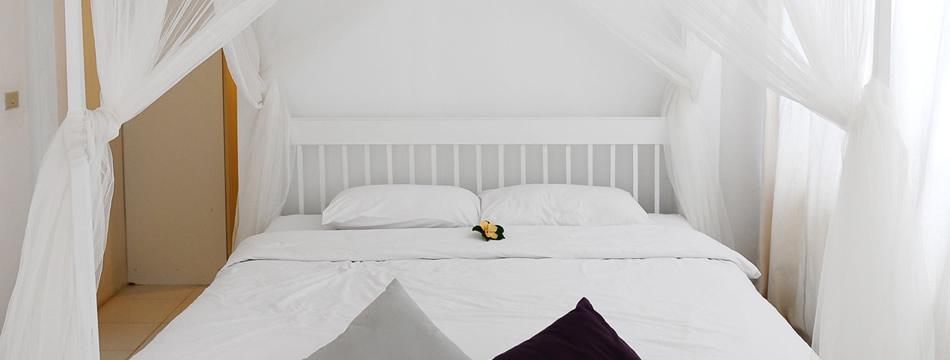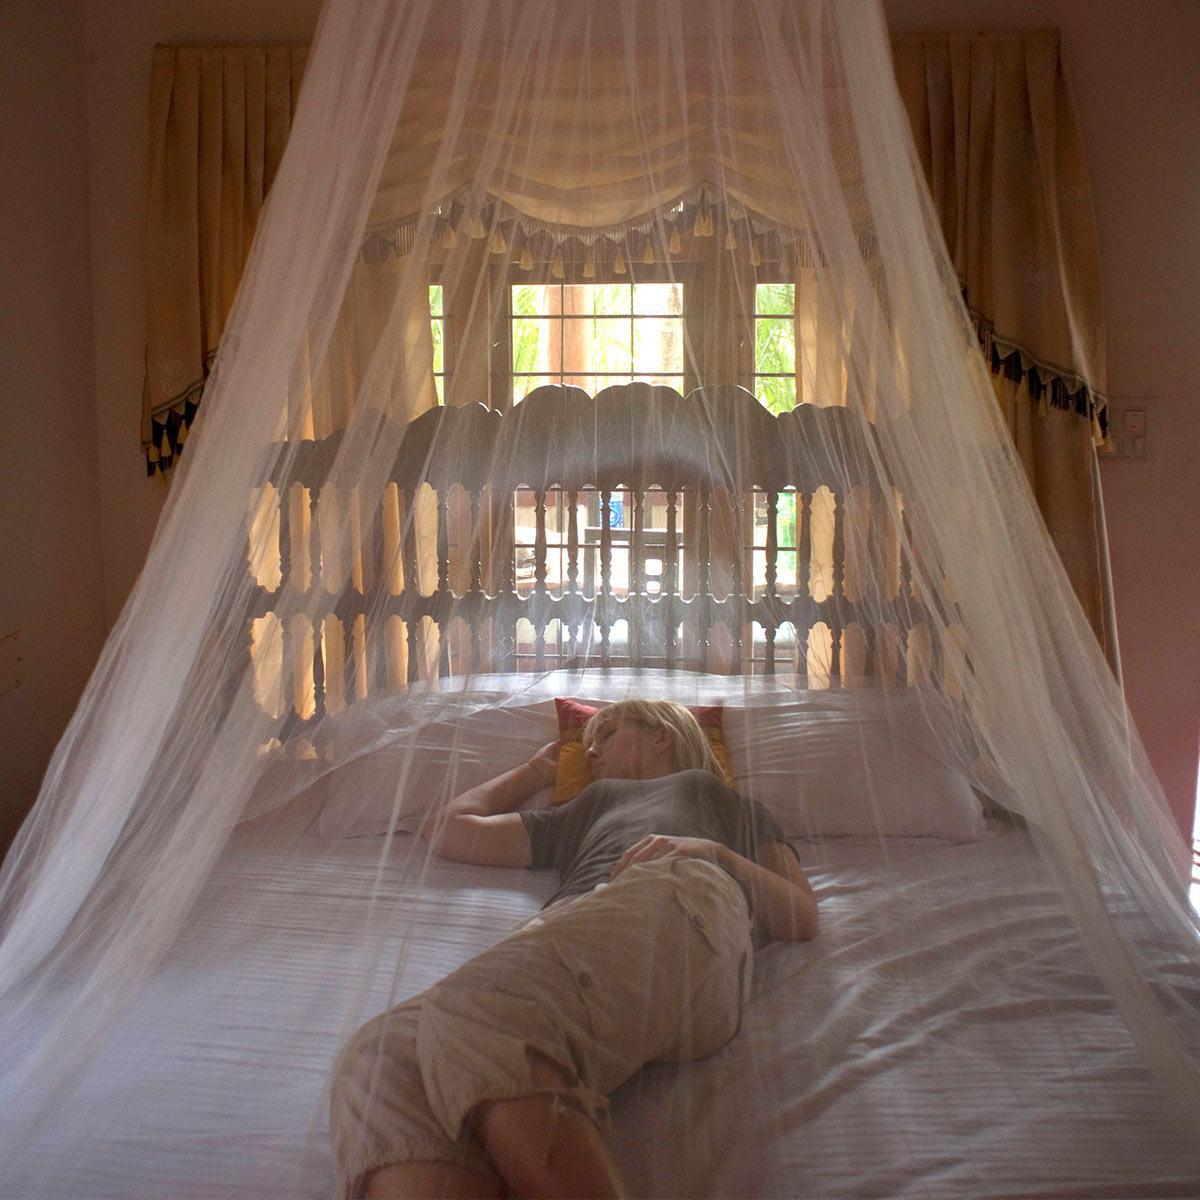The first image is the image on the left, the second image is the image on the right. Examine the images to the left and right. Is the description "Two blue pillows are on a bed under a sheer white canopy that ties at the corners." accurate? Answer yes or no. No. The first image is the image on the left, the second image is the image on the right. For the images displayed, is the sentence "There is no more than 5 pillows." factually correct? Answer yes or no. Yes. 